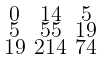<formula> <loc_0><loc_0><loc_500><loc_500>\begin{smallmatrix} 0 & 1 4 & 5 \\ 5 & 5 5 & 1 9 \\ 1 9 & 2 1 4 & 7 4 \end{smallmatrix}</formula> 